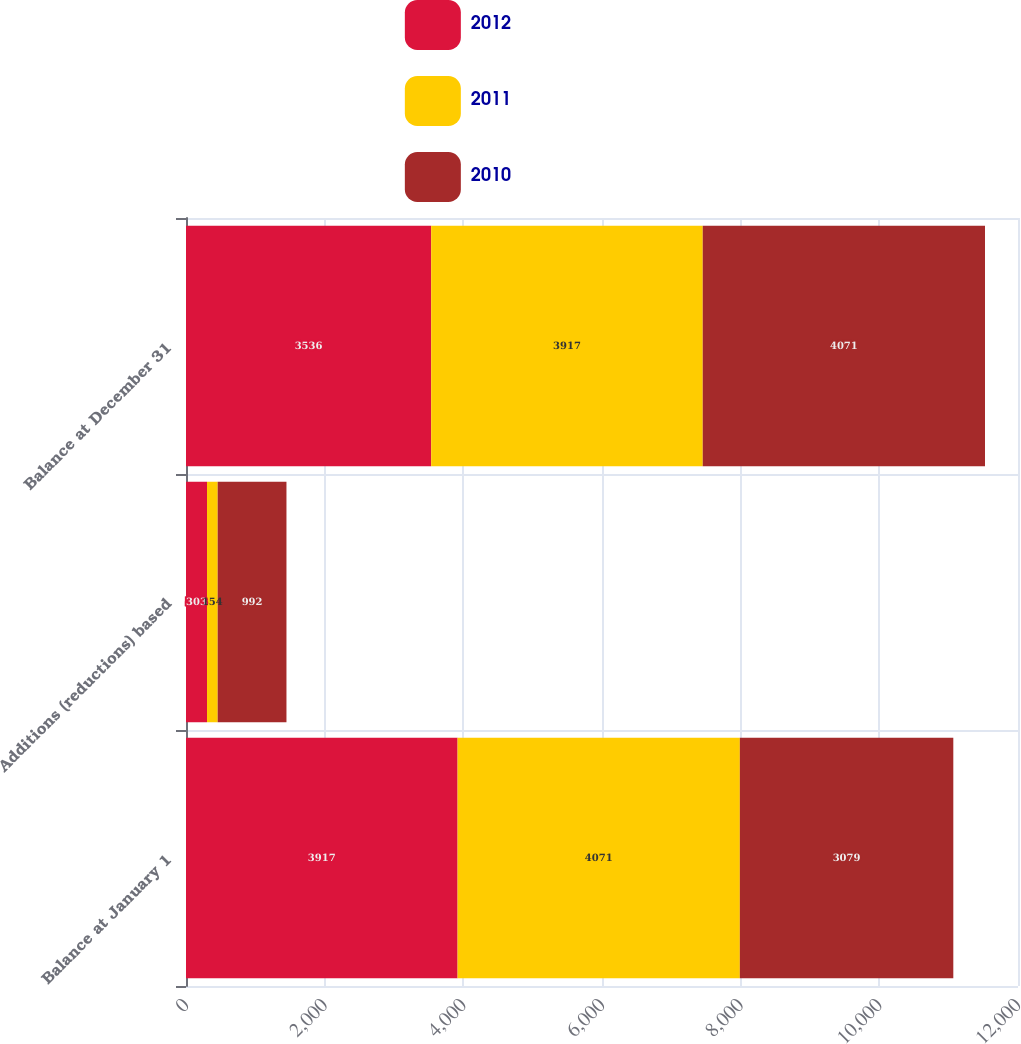<chart> <loc_0><loc_0><loc_500><loc_500><stacked_bar_chart><ecel><fcel>Balance at January 1<fcel>Additions (reductions) based<fcel>Balance at December 31<nl><fcel>2012<fcel>3917<fcel>303<fcel>3536<nl><fcel>2011<fcel>4071<fcel>154<fcel>3917<nl><fcel>2010<fcel>3079<fcel>992<fcel>4071<nl></chart> 